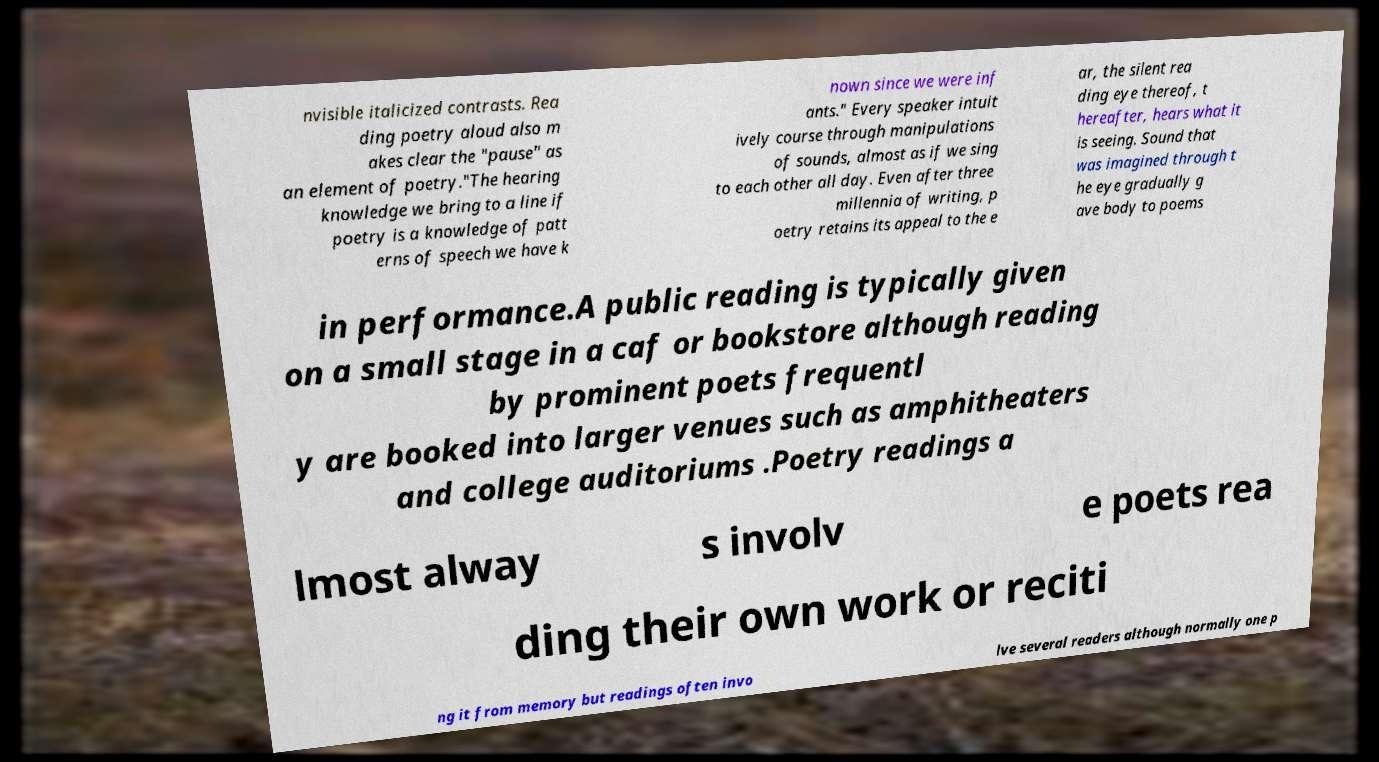Can you accurately transcribe the text from the provided image for me? nvisible italicized contrasts. Rea ding poetry aloud also m akes clear the "pause" as an element of poetry."The hearing knowledge we bring to a line if poetry is a knowledge of patt erns of speech we have k nown since we were inf ants." Every speaker intuit ively course through manipulations of sounds, almost as if we sing to each other all day. Even after three millennia of writing, p oetry retains its appeal to the e ar, the silent rea ding eye thereof, t hereafter, hears what it is seeing. Sound that was imagined through t he eye gradually g ave body to poems in performance.A public reading is typically given on a small stage in a caf or bookstore although reading by prominent poets frequentl y are booked into larger venues such as amphitheaters and college auditoriums .Poetry readings a lmost alway s involv e poets rea ding their own work or reciti ng it from memory but readings often invo lve several readers although normally one p 